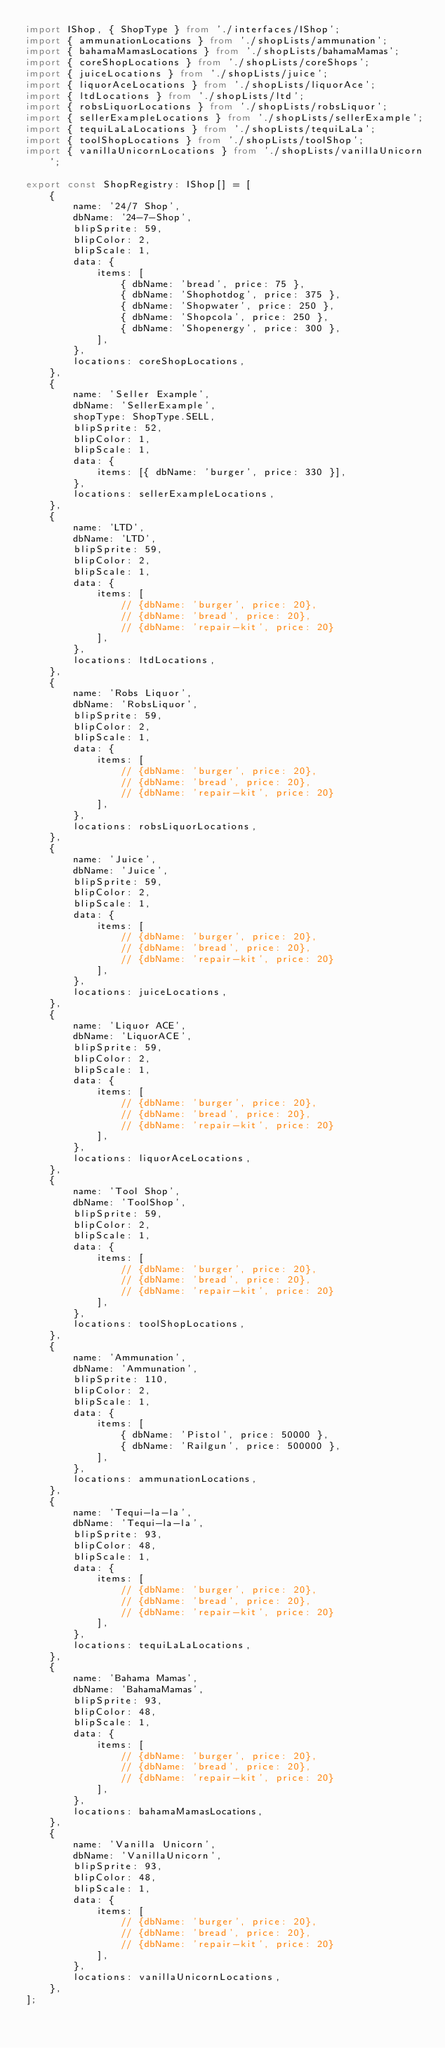Convert code to text. <code><loc_0><loc_0><loc_500><loc_500><_TypeScript_>import IShop, { ShopType } from './interfaces/IShop';
import { ammunationLocations } from './shopLists/ammunation';
import { bahamaMamasLocations } from './shopLists/bahamaMamas';
import { coreShopLocations } from './shopLists/coreShops';
import { juiceLocations } from './shopLists/juice';
import { liquorAceLocations } from './shopLists/liquorAce';
import { ltdLocations } from './shopLists/ltd';
import { robsLiquorLocations } from './shopLists/robsLiquor';
import { sellerExampleLocations } from './shopLists/sellerExample';
import { tequiLaLaLocations } from './shopLists/tequiLaLa';
import { toolShopLocations } from './shopLists/toolShop';
import { vanillaUnicornLocations } from './shopLists/vanillaUnicorn';

export const ShopRegistry: IShop[] = [
    {
        name: '24/7 Shop',
        dbName: '24-7-Shop',
        blipSprite: 59,
        blipColor: 2,
        blipScale: 1,
        data: {
            items: [
                { dbName: 'bread', price: 75 },
                { dbName: 'Shophotdog', price: 375 },
                { dbName: 'Shopwater', price: 250 },
                { dbName: 'Shopcola', price: 250 },
                { dbName: 'Shopenergy', price: 300 },
            ],
        },
        locations: coreShopLocations,
    },
    {
        name: 'Seller Example',
        dbName: 'SellerExample',
        shopType: ShopType.SELL,
        blipSprite: 52,
        blipColor: 1,
        blipScale: 1,
        data: {
            items: [{ dbName: 'burger', price: 330 }],
        },
        locations: sellerExampleLocations,
    },
    {
        name: 'LTD',
        dbName: 'LTD',
        blipSprite: 59,
        blipColor: 2,
        blipScale: 1,
        data: {
            items: [
                // {dbName: 'burger', price: 20},
                // {dbName: 'bread', price: 20},
                // {dbName: 'repair-kit', price: 20}
            ],
        },
        locations: ltdLocations,
    },
    {
        name: 'Robs Liquor',
        dbName: 'RobsLiquor',
        blipSprite: 59,
        blipColor: 2,
        blipScale: 1,
        data: {
            items: [
                // {dbName: 'burger', price: 20},
                // {dbName: 'bread', price: 20},
                // {dbName: 'repair-kit', price: 20}
            ],
        },
        locations: robsLiquorLocations,
    },
    {
        name: 'Juice',
        dbName: 'Juice',
        blipSprite: 59,
        blipColor: 2,
        blipScale: 1,
        data: {
            items: [
                // {dbName: 'burger', price: 20},
                // {dbName: 'bread', price: 20},
                // {dbName: 'repair-kit', price: 20}
            ],
        },
        locations: juiceLocations,
    },
    {
        name: 'Liquor ACE',
        dbName: 'LiquorACE',
        blipSprite: 59,
        blipColor: 2,
        blipScale: 1,
        data: {
            items: [
                // {dbName: 'burger', price: 20},
                // {dbName: 'bread', price: 20},
                // {dbName: 'repair-kit', price: 20}
            ],
        },
        locations: liquorAceLocations,
    },
    {
        name: 'Tool Shop',
        dbName: 'ToolShop',
        blipSprite: 59,
        blipColor: 2,
        blipScale: 1,
        data: {
            items: [
                // {dbName: 'burger', price: 20},
                // {dbName: 'bread', price: 20},
                // {dbName: 'repair-kit', price: 20}
            ],
        },
        locations: toolShopLocations,
    },
    {
        name: 'Ammunation',
        dbName: 'Ammunation',
        blipSprite: 110,
        blipColor: 2,
        blipScale: 1,
        data: {
            items: [
                { dbName: 'Pistol', price: 50000 },
                { dbName: 'Railgun', price: 500000 },
            ],
        },
        locations: ammunationLocations,
    },
    {
        name: 'Tequi-la-la',
        dbName: 'Tequi-la-la',
        blipSprite: 93,
        blipColor: 48,
        blipScale: 1,
        data: {
            items: [
                // {dbName: 'burger', price: 20},
                // {dbName: 'bread', price: 20},
                // {dbName: 'repair-kit', price: 20}
            ],
        },
        locations: tequiLaLaLocations,
    },
    {
        name: 'Bahama Mamas',
        dbName: 'BahamaMamas',
        blipSprite: 93,
        blipColor: 48,
        blipScale: 1,
        data: {
            items: [
                // {dbName: 'burger', price: 20},
                // {dbName: 'bread', price: 20},
                // {dbName: 'repair-kit', price: 20}
            ],
        },
        locations: bahamaMamasLocations,
    },
    {
        name: 'Vanilla Unicorn',
        dbName: 'VanillaUnicorn',
        blipSprite: 93,
        blipColor: 48,
        blipScale: 1,
        data: {
            items: [
                // {dbName: 'burger', price: 20},
                // {dbName: 'bread', price: 20},
                // {dbName: 'repair-kit', price: 20}
            ],
        },
        locations: vanillaUnicornLocations,
    },
];
</code> 